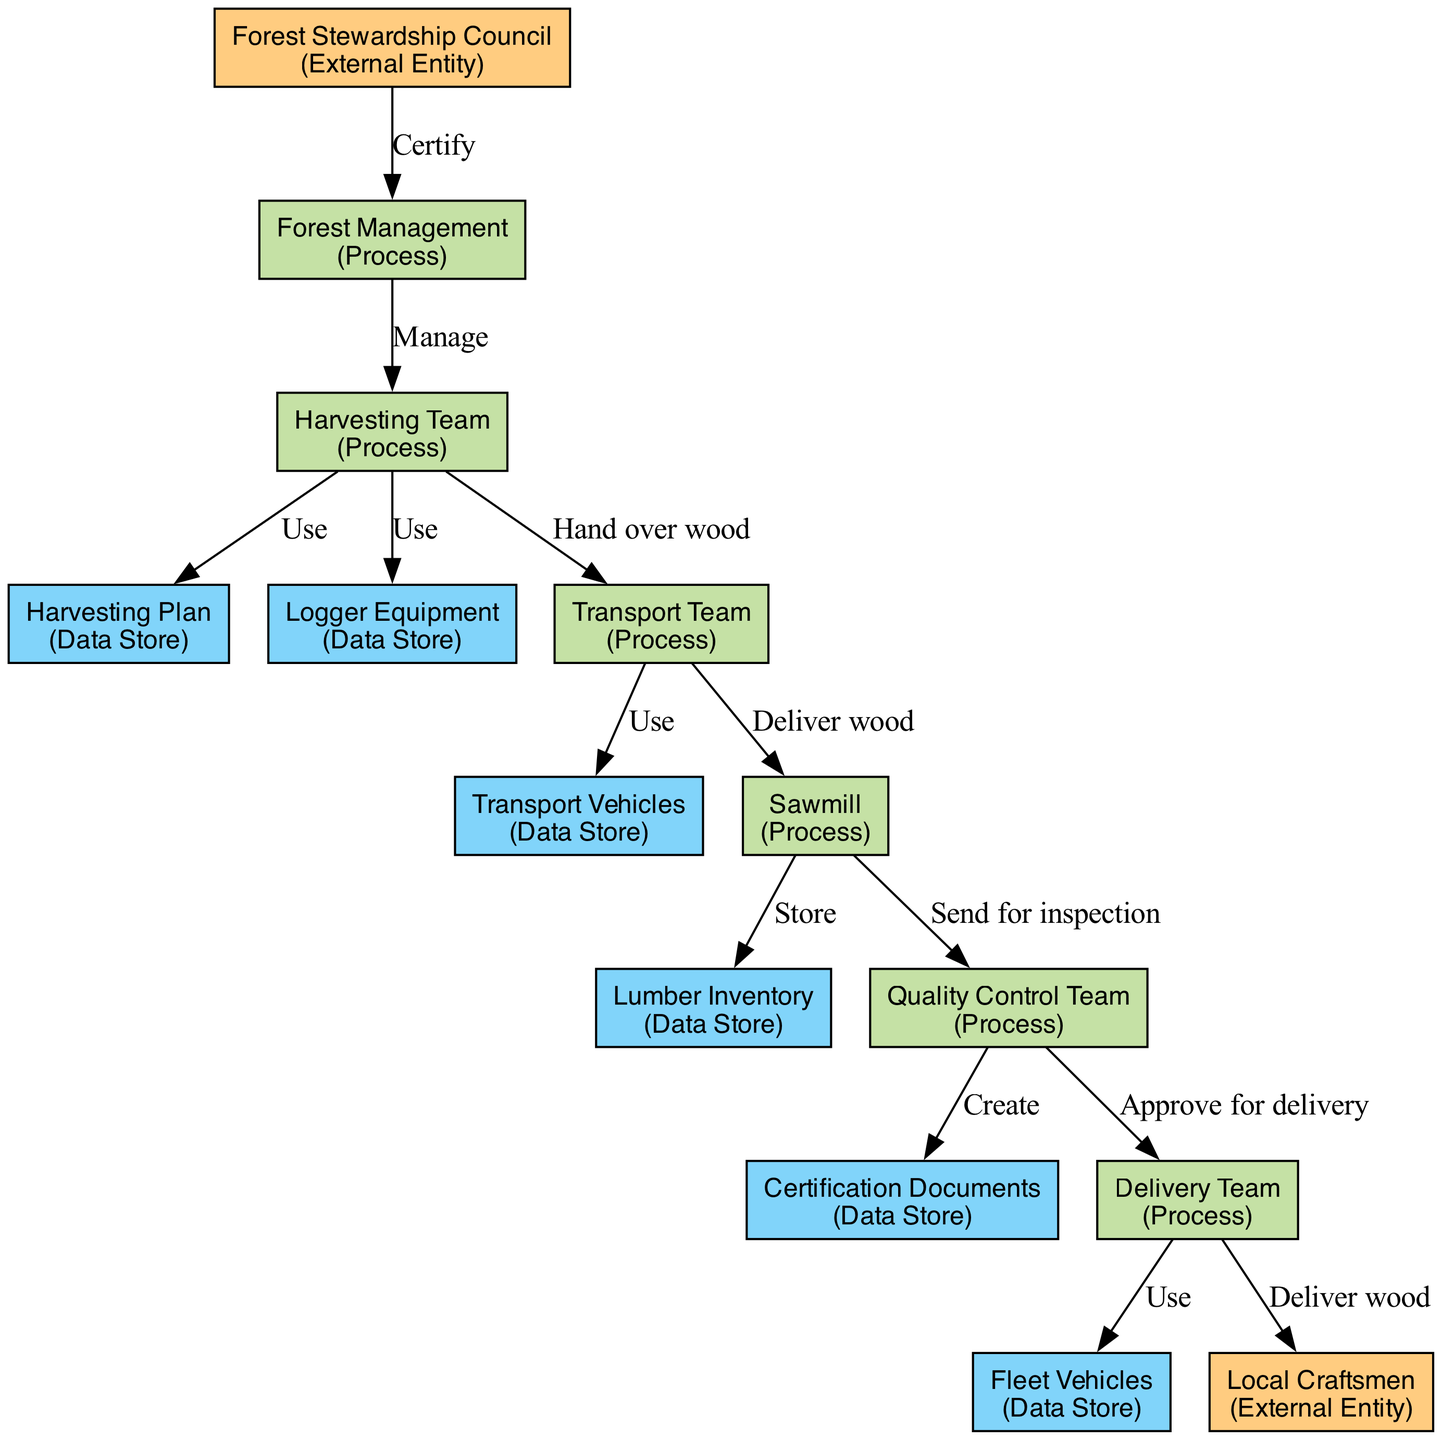What is the first process listed in the diagram? The first process listed is "Forest Management", which serves as the starting point for overseeing sustainable practices.
Answer: Forest Management How many data stores are represented in the diagram? There are five data stores in the diagram: Harvesting Plan, Logger Equipment, Lumber Inventory, Certification Documents, and Fleet Vehicles.
Answer: 5 Which external entity certifies forest management practices? The external entity responsible for certification is the "Forest Stewardship Council".
Answer: Forest Stewardship Council What is the role of the Quality Control Team in the process? The Quality Control Team inspects the lumber and creates certification documents, acting as a gatekeeper for quality before delivery.
Answer: Ensure quality What comes after the Sawmill in the flow of the diagram? After the Sawmill, the processed wood is sent to the Quality Control Team for inspection, indicating a quality assurance step before delivery.
Answer: Quality Control Team Who uses the Logger Equipment according to the diagram? The "Harvesting Team" is responsible for using the Logger Equipment during the logging process.
Answer: Harvesting Team What is delivered to the Local Craftsmen? The Delivery Team handles the logistics to deliver processed wood to the Local Craftsmen for their traditional craftsmanship.
Answer: Processed wood Which process is responsible for transporting wood from the forest? The "Transport Team" is specifically tasked with managing the transportation of harvested wood from the forest to the sawmill.
Answer: Transport Team What is the connection between the Quality Control Team and the Delivery Team? The Quality Control Team approves processed lumber for delivery and sends it to the Delivery Team, ensuring quality before distribution.
Answer: Approve for delivery 